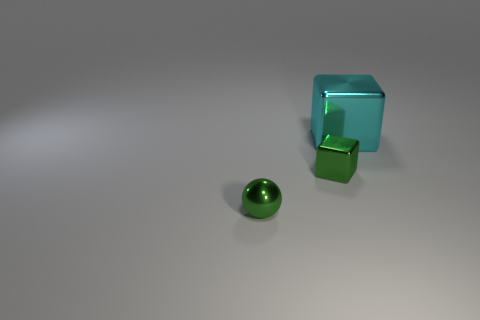Does the green shiny object that is behind the green ball have the same size as the tiny shiny sphere?
Provide a succinct answer. Yes. Are there fewer small metallic cubes than cyan matte blocks?
Provide a succinct answer. No. What is the shape of the cyan object that is right of the small shiny object that is on the left side of the block that is on the left side of the large cyan block?
Your answer should be compact. Cube. Is there a cyan block that has the same material as the tiny green sphere?
Your answer should be very brief. Yes. Do the block that is on the left side of the cyan thing and the thing in front of the small cube have the same color?
Ensure brevity in your answer.  Yes. Are there fewer big cyan shiny objects in front of the tiny shiny block than big red metal cylinders?
Your answer should be very brief. No. How many things are purple objects or metal objects left of the large object?
Your answer should be very brief. 2. There is a small ball that is the same material as the big cyan thing; what color is it?
Keep it short and to the point. Green. How many objects are spheres or big shiny things?
Your answer should be very brief. 2. There is a metallic thing that is the same size as the green metal sphere; what color is it?
Offer a very short reply. Green. 